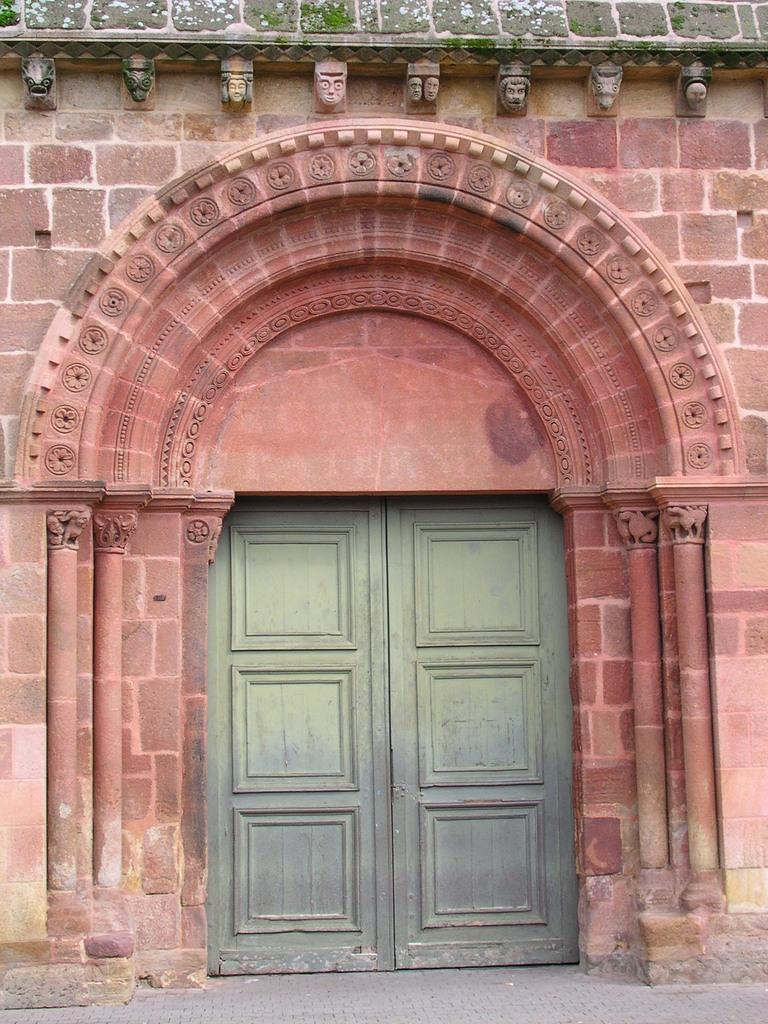What type of structure is visible in the image? There is a building in the image. What can be seen in the foreground of the image? There is a door in the foreground of the image. Are there any decorative elements on the building? Yes, there are pillars with sculptures in the image. What type of vegetation is present on the wall in the image? There are plants on the wall in the image. What is visible at the bottom of the image? There is a road at the bottom of the image. How many pins are used to hold the unit together in the image? There are no pins or units present in the image; it features a building with a door, pillars, plants, and a road. 